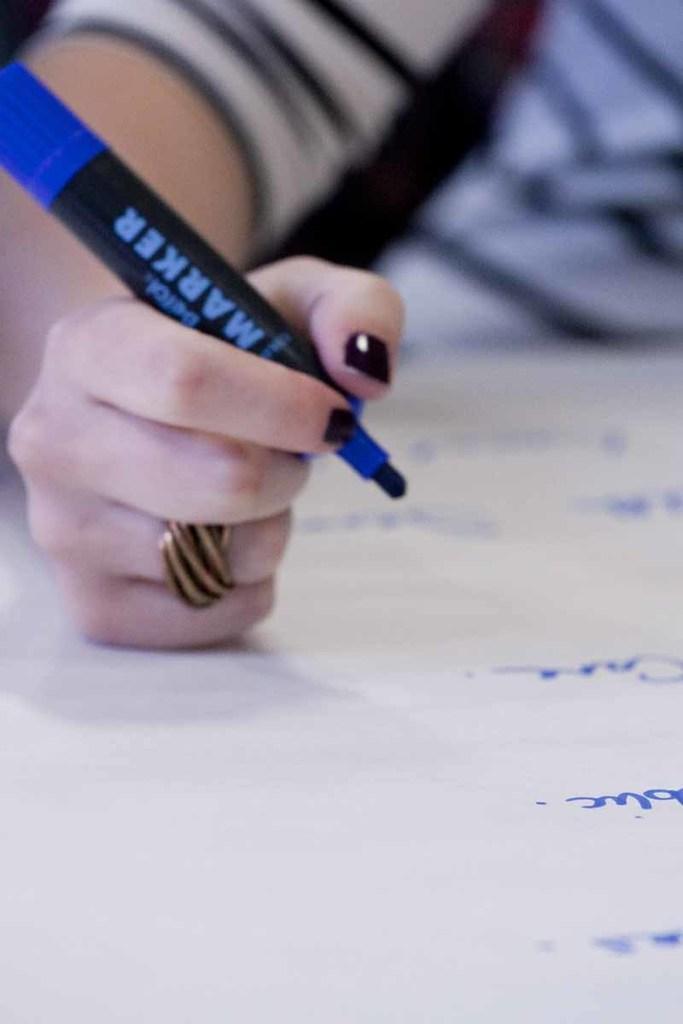Please provide a concise description of this image. In this image, we can see a person holding a marker and wearing a ring. At the bottom, there is some text on the paper. 